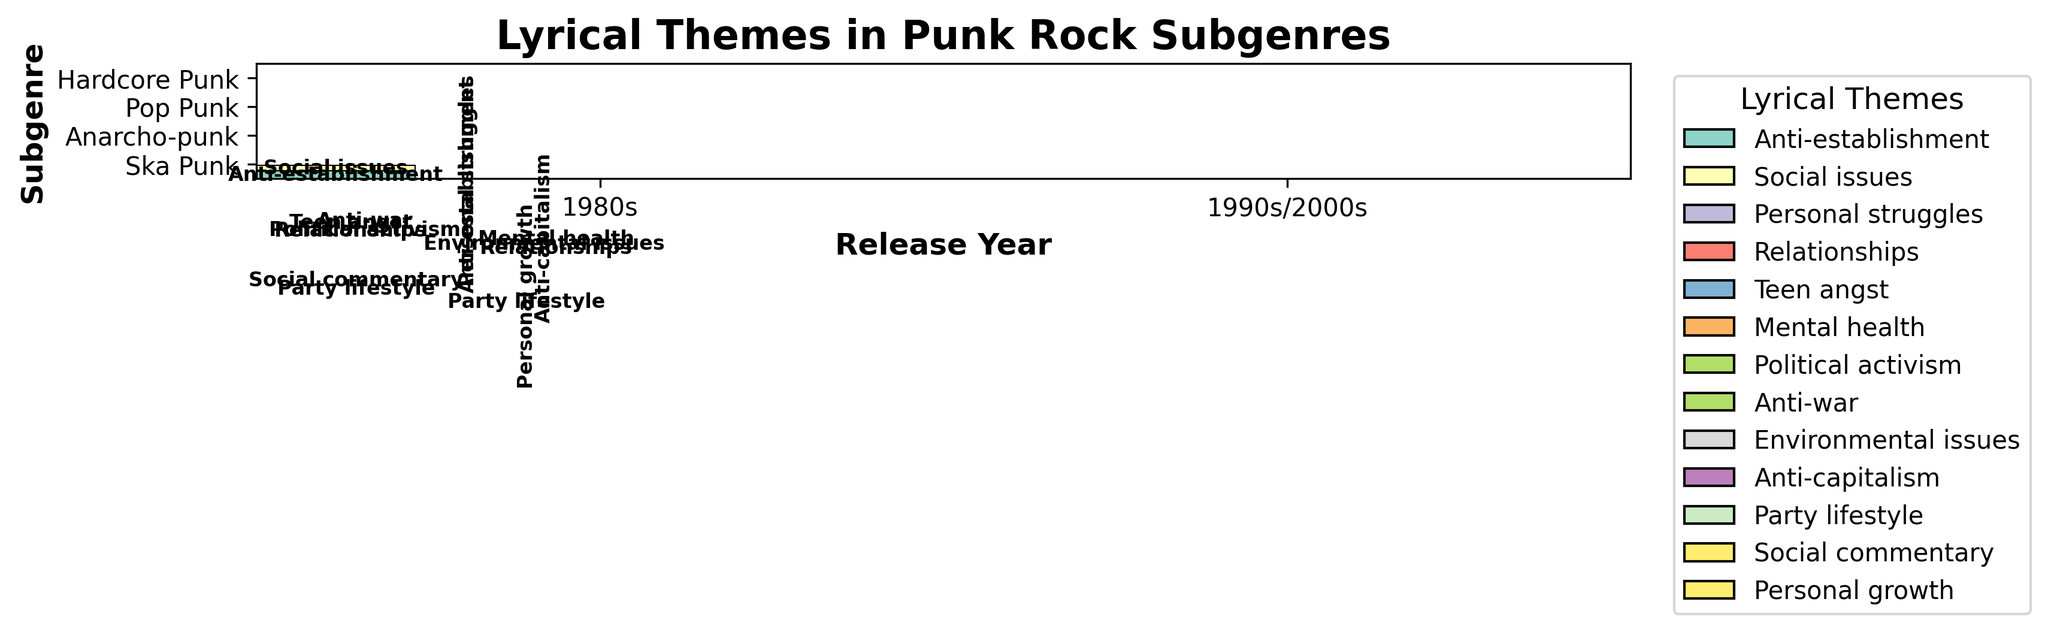Which subgenre has the most diverse lyrical themes in the 1990s? Look for the subgenre in the 1990s that has the highest count of different themes. Hardcore Punk has themes like Anti-establishment and Personal struggles, Pop Punk has Relationships and Teen angst, Anarcho-punk has Environmental issues and Anti-capitalism, and Ska Punk has Party lifestyle and Social commentary. All these subgenres have equal diversity in themes.
Answer: Hardcore Punk, Pop Punk, Anarcho-punk, Ska Punk Which subgenre and release decade had the highest count for a single lyrical theme? Find the largest rectangle in the mosaic plot which represents the highest single count. The largest rectangle is for 'Relationships' in Pop Punk during the 2000s.
Answer: Pop Punk, 2000s What's the common lyrical theme in 1980s Anarcho-punk songs? Look for the rectangles associated with Anarcho-punk subgenre for the 1980s. The themes are Political activism and Anti-war.
Answer: Political activism, Anti-war Which lyrical theme in Pop Punk songs shows an increasing trend from the 1990s to the 2000s? Compare the rectangles for Pop Punk between the 1990s and 2000s. Relationships show an increase in count, whereas Teen angst isn't present in the 2000s.
Answer: Relationships Is there a lyrical theme that appears in all subgenres? Check each subgenre for recurring themes. There isn't any single theme that appears across all subgenres.
Answer: No Which subgenres are present in the 2000s? Observe the subgenres mentioned along the y-axis corresponding to the 2000s. Pop Punk and Ska Punk are present.
Answer: Pop Punk, Ska Punk What is the total count of 'Anti-establishment' theme in Hardcore Punk songs across all decades? Sum the counts of 'Anti-establishment' theme in Hardcore Punk across the 1980s and 1990s. The counts are 15 + 10.
Answer: 25 Which subgenre has the theme 'Party lifestyle' and in which decades does it appear? 'Party lifestyle' appears in the Ska Punk subgenre in the 1990s and 2000s. Look at the rectangles corresponding to Ska Punk.
Answer: Ska Punk, 1990s, 2000s Which subgenre has the least presence in the 2000s? Compare the heights of rectangles in the 2000s. Anarcho-punk does not appear in the 2000s.
Answer: Anarcho-punk What are the lyrical themes for Hardcore Punk in the 1980s? Look for the rectangles corresponding to Hardcore Punk in the 1980s. The themes are Anti-establishment and Social issues.
Answer: Anti-establishment, Social issues 